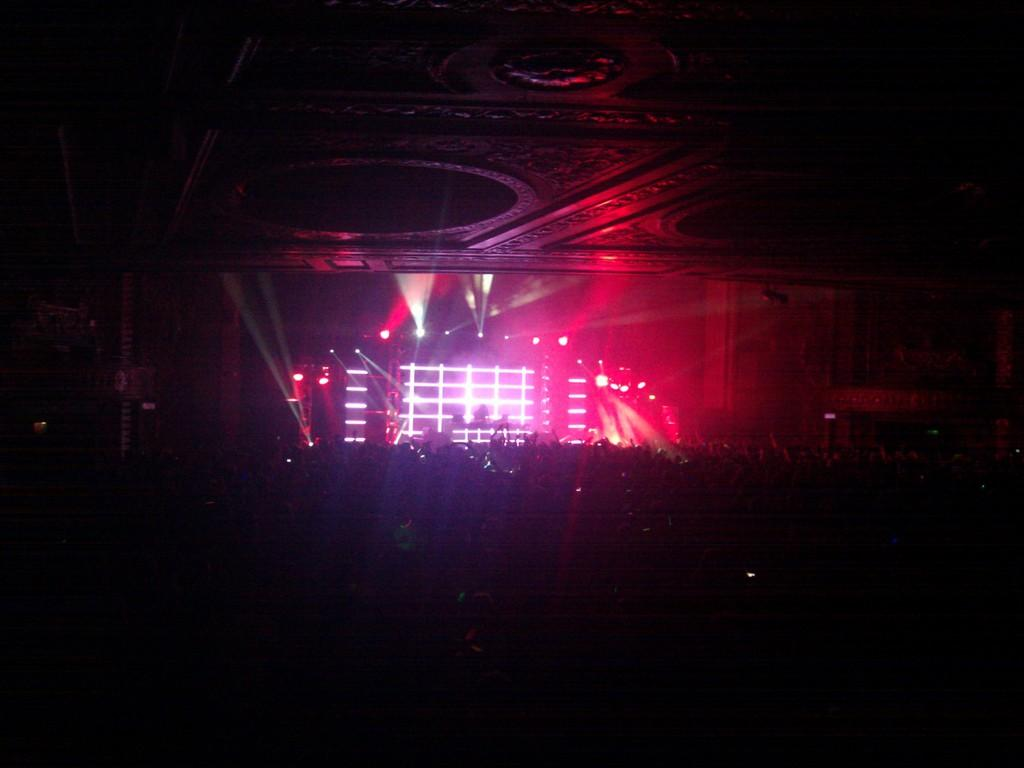What is the main feature of the image? There is a stage in the image. What can be seen on the stage? Focus lights are present on the stage. What is visible at the top of the image? The ceiling is visible at the top of the image. How would you describe the lighting in the image? The background of the image is dark. How many oranges are stacked on the brick wall in the image? There are no oranges or brick walls present in the image. What type of vacation is being depicted in the image? The image does not depict a vacation; it features a stage with focus lights and a dark background. 